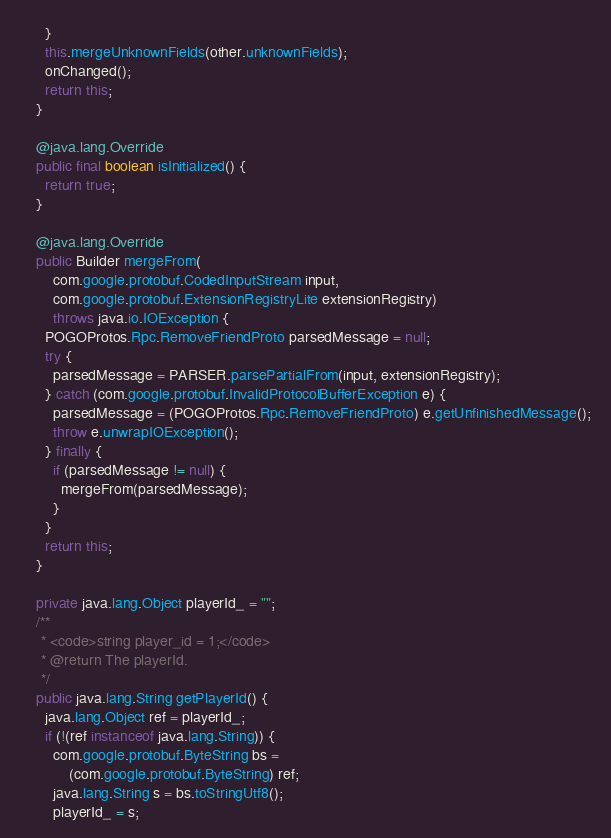Convert code to text. <code><loc_0><loc_0><loc_500><loc_500><_Java_>      }
      this.mergeUnknownFields(other.unknownFields);
      onChanged();
      return this;
    }

    @java.lang.Override
    public final boolean isInitialized() {
      return true;
    }

    @java.lang.Override
    public Builder mergeFrom(
        com.google.protobuf.CodedInputStream input,
        com.google.protobuf.ExtensionRegistryLite extensionRegistry)
        throws java.io.IOException {
      POGOProtos.Rpc.RemoveFriendProto parsedMessage = null;
      try {
        parsedMessage = PARSER.parsePartialFrom(input, extensionRegistry);
      } catch (com.google.protobuf.InvalidProtocolBufferException e) {
        parsedMessage = (POGOProtos.Rpc.RemoveFriendProto) e.getUnfinishedMessage();
        throw e.unwrapIOException();
      } finally {
        if (parsedMessage != null) {
          mergeFrom(parsedMessage);
        }
      }
      return this;
    }

    private java.lang.Object playerId_ = "";
    /**
     * <code>string player_id = 1;</code>
     * @return The playerId.
     */
    public java.lang.String getPlayerId() {
      java.lang.Object ref = playerId_;
      if (!(ref instanceof java.lang.String)) {
        com.google.protobuf.ByteString bs =
            (com.google.protobuf.ByteString) ref;
        java.lang.String s = bs.toStringUtf8();
        playerId_ = s;</code> 